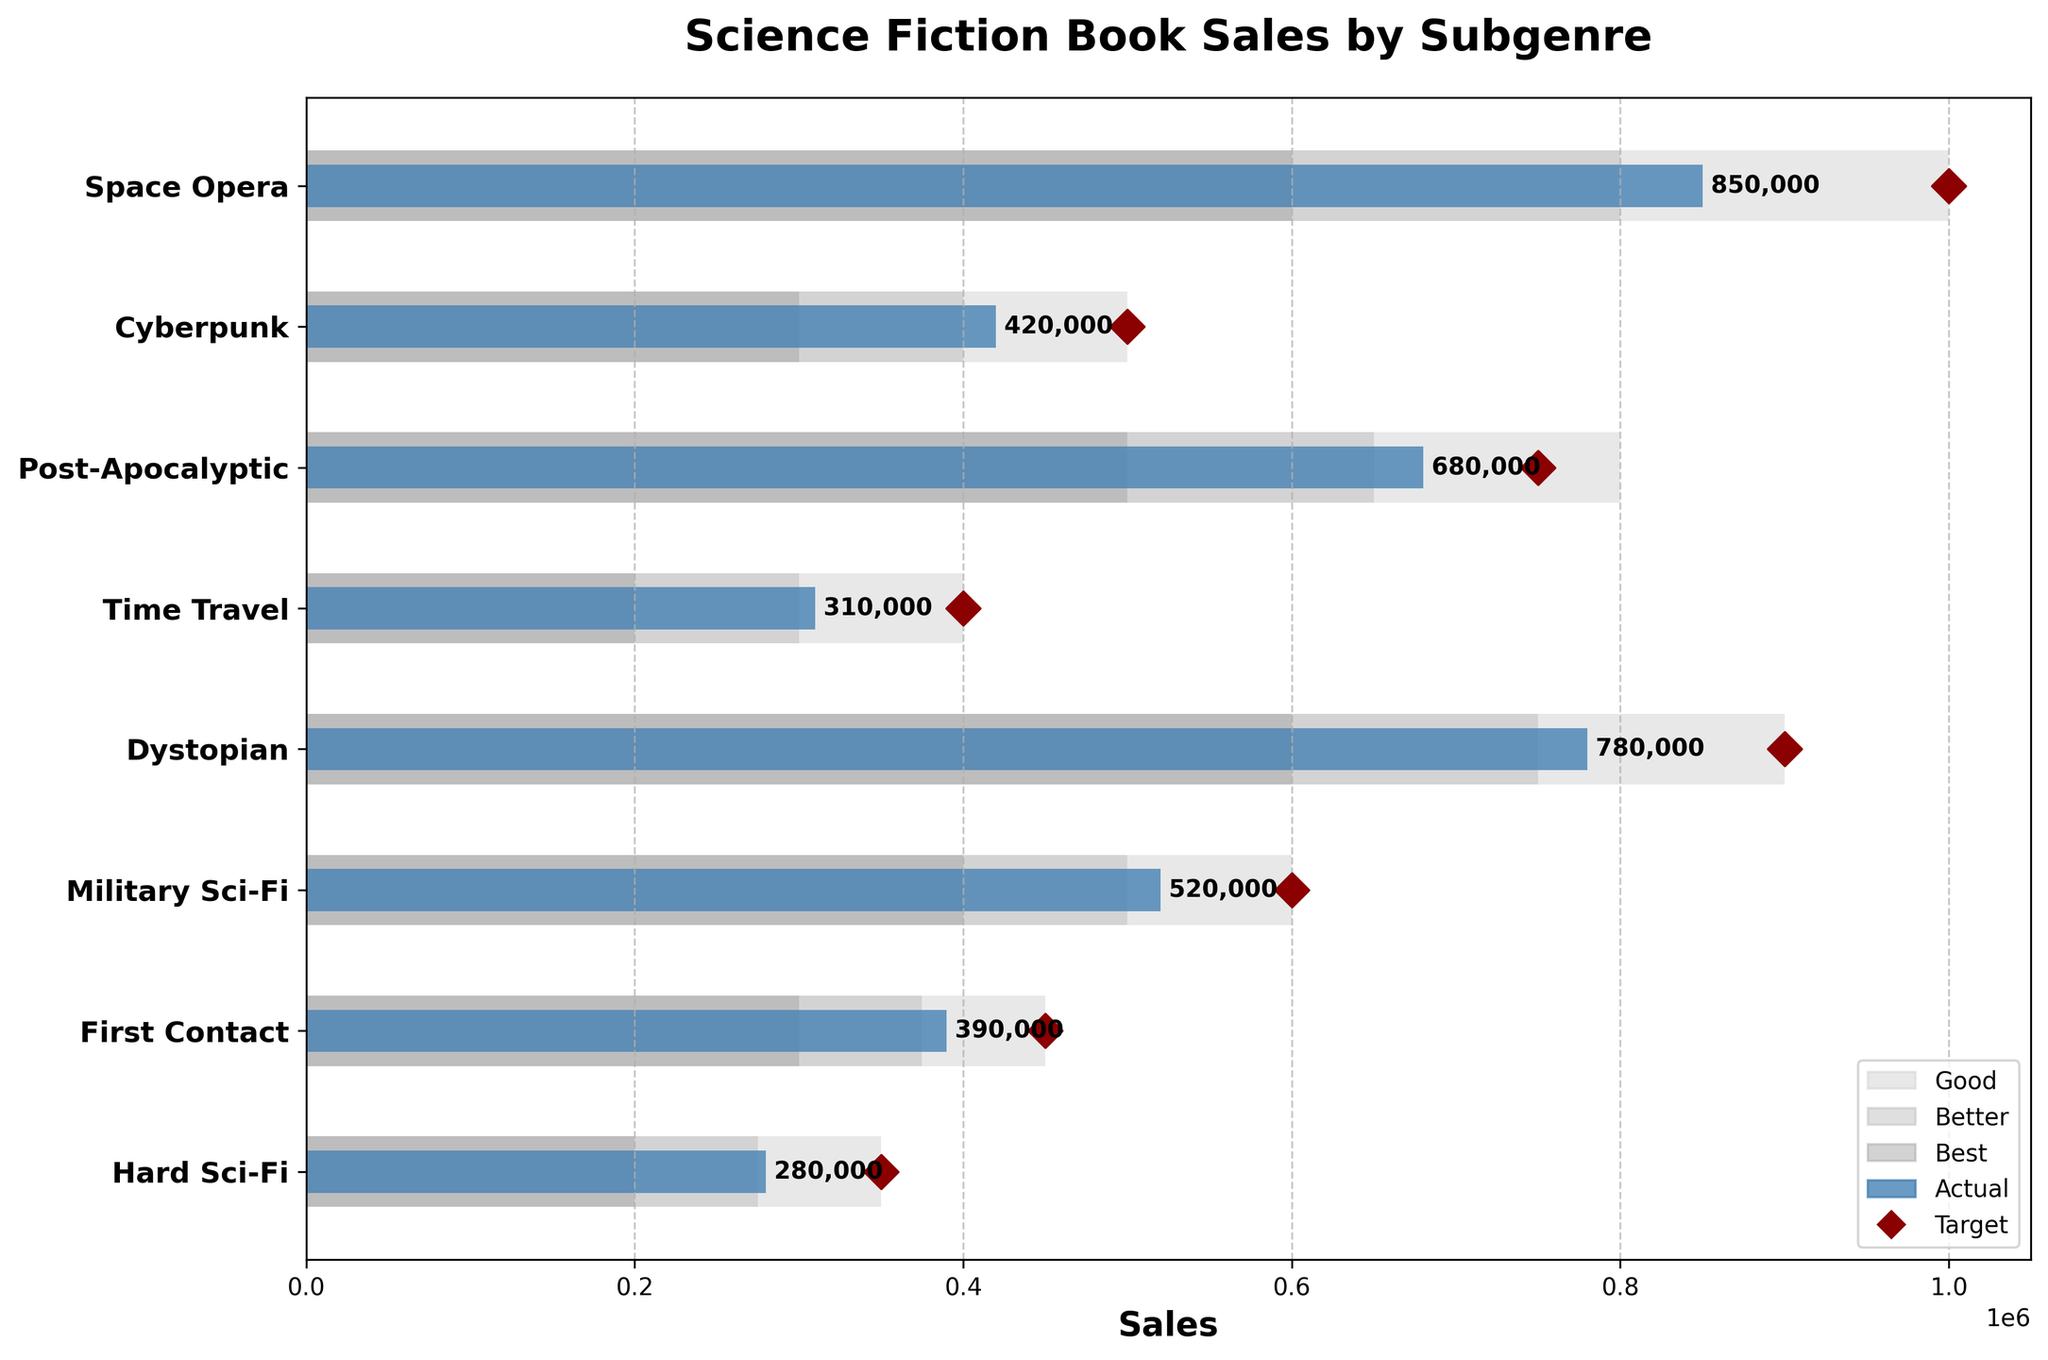What is the title of the figure? The title of the figure is located at the top and summarizes the content, which is "Science Fiction Book Sales by Subgenre".
Answer: Science Fiction Book Sales by Subgenre Which subgenre has the highest actual sales? By observing the farthest blue bar to the right, "Space Opera" has the highest actual sales.
Answer: Space Opera What are the three range categories represented in the plot? The legend at the bottom right shows the three range categories as "Good" (light grey), "Better" (silver), and "Best" (dark grey).
Answer: Good, Better, Best How do the actual sales of "Cyberpunk" compare to its target sales? The blue bar for "Cyberpunk" reaches 420,000 while the dark red diamond marker (target) is at 500,000, indicating that the actual sales are below the target.
Answer: Below Which subgenre has its actual sales very close to its target sales? By examining the proximity of blue bars to the dark red diamond markers, "Military Sci-Fi" has actual sales very close to its target.
Answer: Military Sci-Fi Are there any subgenres where the actual sales exceed the best range? The "Post-Apocalyptic" subgenre has actual sales (680,000) that go beyond its best range limit (800,000), indicating it exceeds the best range.
Answer: No Which subgenre needs the most improvement to reach its target sales? By comparing the difference between actual and target sales, "Hard Sci-Fi" has the largest gap (350,000 - 280,000 = 70,000).
Answer: Hard Sci-Fi How many subgenres have actual sales within the "Best" range? By checking the placement of the blue bars within the darkest grey range, "Space Opera", "Cyberpunk", "Post-Apocalyptic", "Dystopian", "Military Sci-Fi" and "First Contact" are within the "Best" range.
Answer: 6 Which subgenre has the shortest blue bar, and what does it indicate? The shortest blue bar is for "Hard Sci-Fi", indicating it has the lowest actual sales among all subgenres.
Answer: Hard Sci-Fi Which subgenre's actual sales are closest to being in the "Best" category, but are currently in the "Better" category? By assessing the blue bars just below the darkest grey range, "Time Travel" is in the "Better" (silver) category and closest to the "Best" (dark grey).
Answer: Time Travel 